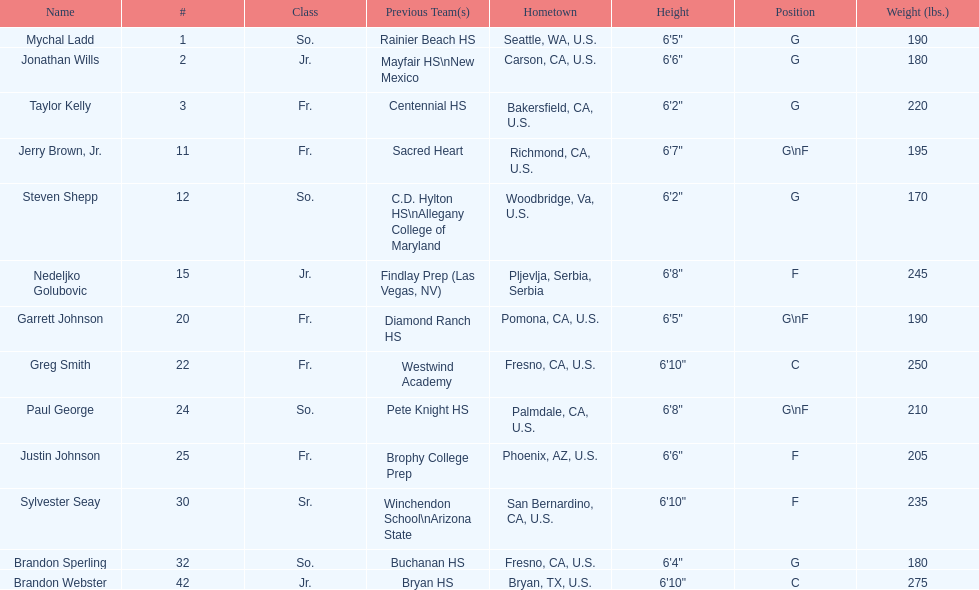What are the listed classes of the players? So., Jr., Fr., Fr., So., Jr., Fr., Fr., So., Fr., Sr., So., Jr. Which of these is not from the us? Jr. To which name does that entry correspond to? Nedeljko Golubovic. 